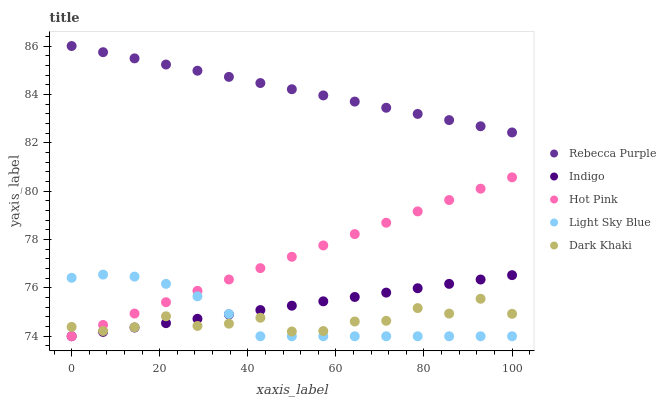Does Dark Khaki have the minimum area under the curve?
Answer yes or no. Yes. Does Rebecca Purple have the maximum area under the curve?
Answer yes or no. Yes. Does Hot Pink have the minimum area under the curve?
Answer yes or no. No. Does Hot Pink have the maximum area under the curve?
Answer yes or no. No. Is Indigo the smoothest?
Answer yes or no. Yes. Is Dark Khaki the roughest?
Answer yes or no. Yes. Is Hot Pink the smoothest?
Answer yes or no. No. Is Hot Pink the roughest?
Answer yes or no. No. Does Hot Pink have the lowest value?
Answer yes or no. Yes. Does Rebecca Purple have the lowest value?
Answer yes or no. No. Does Rebecca Purple have the highest value?
Answer yes or no. Yes. Does Hot Pink have the highest value?
Answer yes or no. No. Is Hot Pink less than Rebecca Purple?
Answer yes or no. Yes. Is Rebecca Purple greater than Light Sky Blue?
Answer yes or no. Yes. Does Light Sky Blue intersect Hot Pink?
Answer yes or no. Yes. Is Light Sky Blue less than Hot Pink?
Answer yes or no. No. Is Light Sky Blue greater than Hot Pink?
Answer yes or no. No. Does Hot Pink intersect Rebecca Purple?
Answer yes or no. No. 